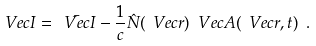Convert formula to latex. <formula><loc_0><loc_0><loc_500><loc_500>\ V e c { I } = \bar { \ V e c { I } } - \frac { 1 } { c } \hat { N } ( \ V e c { r } ) \ V e c { A } ( \ V e c { r } , t ) \ .</formula> 